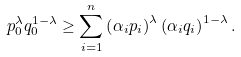<formula> <loc_0><loc_0><loc_500><loc_500>p _ { 0 } ^ { \lambda } q _ { 0 } ^ { 1 - \lambda } \geq \sum _ { i = 1 } ^ { n } \left ( \alpha _ { i } p _ { i } \right ) ^ { \lambda } \left ( \alpha _ { i } q _ { i } \right ) ^ { 1 - \lambda } .</formula> 